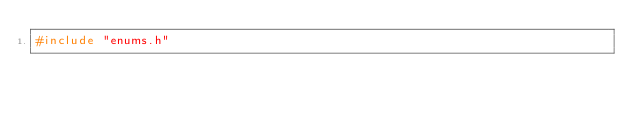<code> <loc_0><loc_0><loc_500><loc_500><_C++_>#include "enums.h"
</code> 